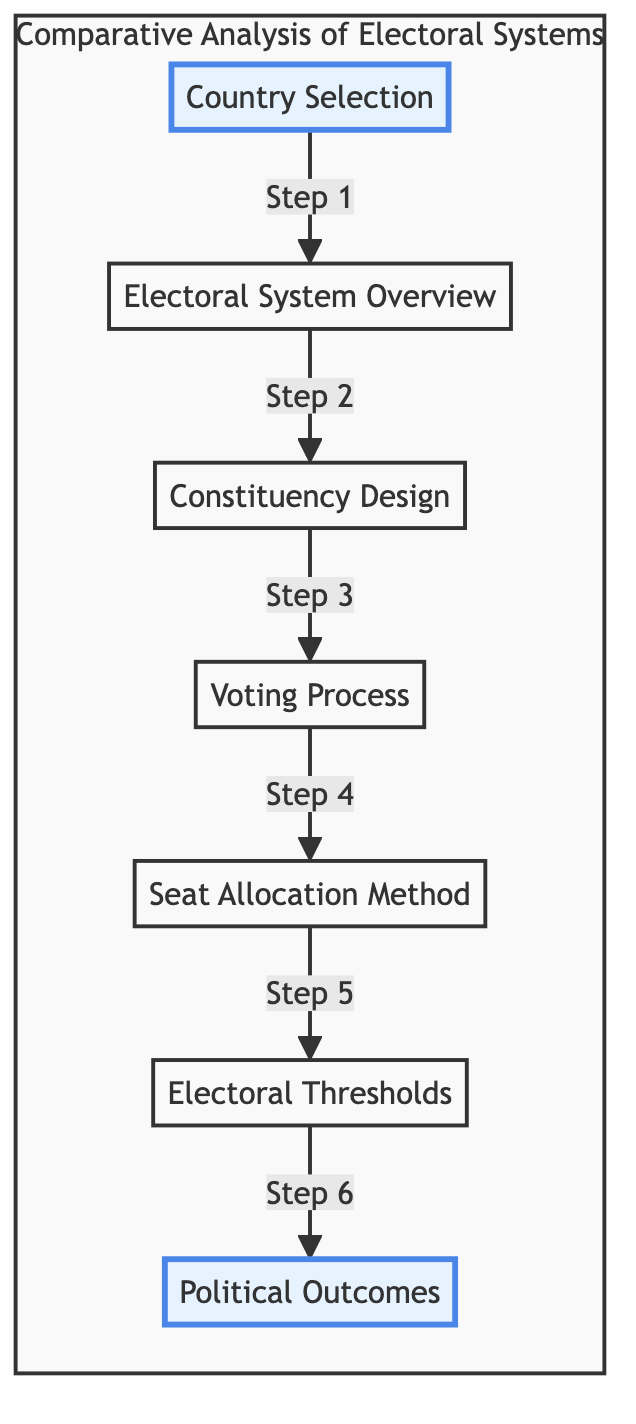What is the first stage in the comparative analysis? The first stage is labeled "Country Selection," which identifies major European countries for comparison.
Answer: Country Selection How many stages are in the flowchart? The flowchart contains seven stages, including the starting point of country selection and the final political outcomes.
Answer: Seven What is the title of the last step in the flowchart? The last step is titled "Political Outcomes," analyzing electoral outcomes, stability of governments, and party systems.
Answer: Political Outcomes Which step directly follows the "Voting Process"? The step that directly follows "Voting Process" is "Seat Allocation Method."
Answer: Seat Allocation Method What electoral system is common in several European countries compared in this flowchart? The electoral systems mentioned include Proportional Representation, First-Past-The-Post, and Mixed-Member Proportional.
Answer: Proportional Representation What type of question do the steps in the flowchart represent? The steps represent a sequential analysis of electoral systems, illustrating procedural differences and outcomes across countries.
Answer: Sequential analysis Why is the "Electoral Thresholds" step important in the flowchart? The "Electoral Thresholds" step is important because it discusses any thresholds for winning seats and their effects on smaller parties.
Answer: It affects smaller parties How does the flow of the diagram help understand electoral systems? The flow of the diagram guides the viewer through systematic comparisons of each electoral aspect, from selection to outcomes, facilitating comprehension of the processes.
Answer: Systematic comparisons 